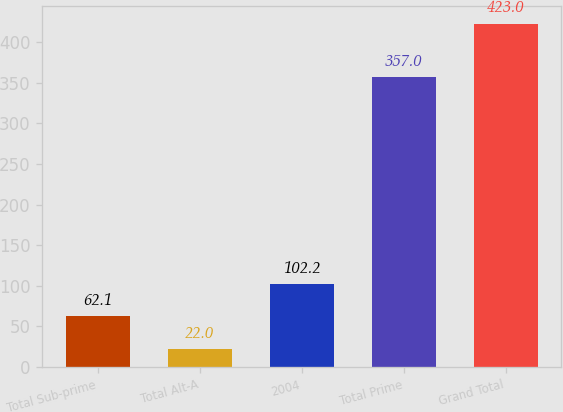Convert chart to OTSL. <chart><loc_0><loc_0><loc_500><loc_500><bar_chart><fcel>Total Sub-prime<fcel>Total Alt-A<fcel>2004<fcel>Total Prime<fcel>Grand Total<nl><fcel>62.1<fcel>22<fcel>102.2<fcel>357<fcel>423<nl></chart> 